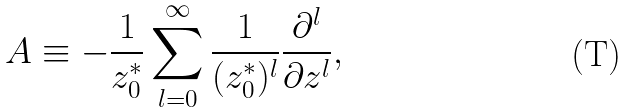Convert formula to latex. <formula><loc_0><loc_0><loc_500><loc_500>A \equiv - \frac { 1 } { z _ { 0 } ^ { * } } \sum _ { l = 0 } ^ { \infty } \frac { 1 } { ( z _ { 0 } ^ { * } ) ^ { l } } \frac { \partial ^ { l } } { \partial z ^ { l } } ,</formula> 